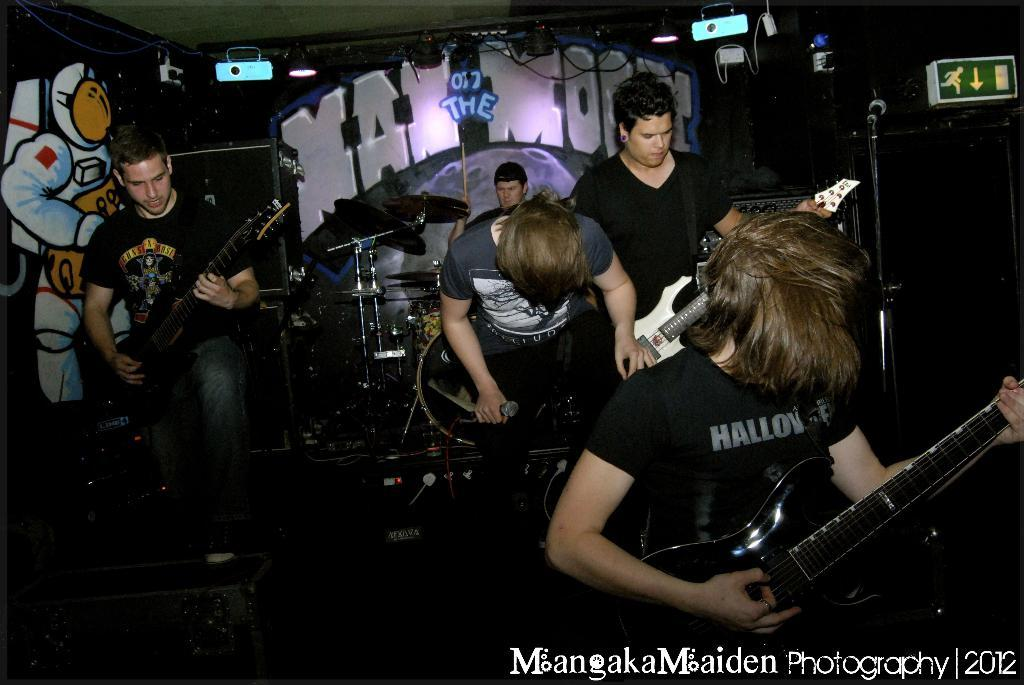Who or what is present in the image? There are people in the image. What are the people holding? The people are holding guitars. What else can be seen in the background of the image? There are musical drums in the background of the image. Can you tell me how many yaks are playing the drums in the image? There are no yaks present in the image, and therefore no such activity can be observed. 